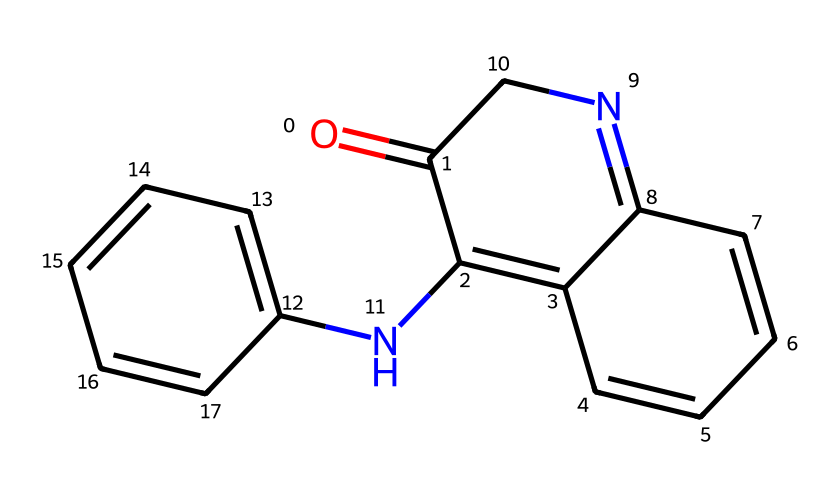How many nitrogen atoms are present in this chemical? By examining the SMILES representation, we can identify two nitrogen atoms represented by the "N" in the structure. Therefore, we count the occurrences of "N" to determine the total.
Answer: two What is the core structure of this chemical? The core structure of this chemical is based on an imide, which includes specific components like carbonyl (C=O) and nitrogen atoms. By observing the SMILES, the cyclic structures containing these elements indicate it is an imide.
Answer: imide How many rings are present in the structure? By analyzing the SMILES representation, there are three distinct ring systems indicated by the numbers (1, 2, and 3), suggesting a fused ring system. We can count these indices to find the number of rings involved.
Answer: three What type of dye is represented by this chemical? This chemical is known as indigo, which historically has been used as a dye. The presence of specific aromatic rings and the nitrogen in the structure typically associates it with dyes rather than pigments.
Answer: indigo Which functional groups are present in this imide structure? The analysis of the chemical structure reveals the presence of carbonyl and nitrogen functional groups, characteristic of imides. The "C=O" denotes the carbonyl, while "N" indicates the nitrogen characteristic of the imide functional group.
Answer: carbonyl and nitrogen What color is the dye derived from this chemical usually associated with? Indigo dye is typically associated with the color blue, which is a significant aspect in various cultural and religious textiles. Its historical use in different regions highlights this specific color association.
Answer: blue 